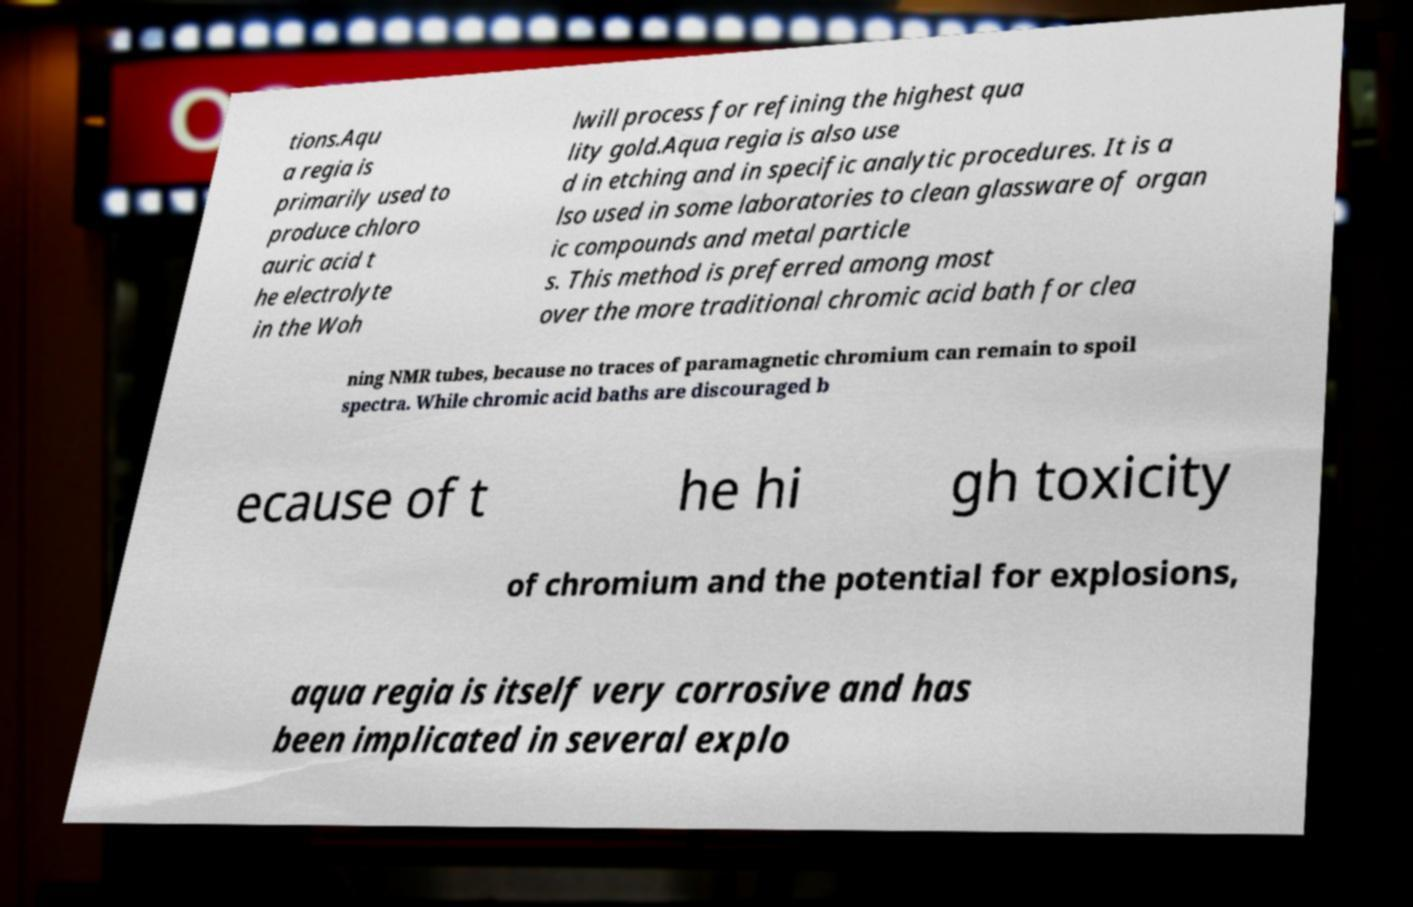What messages or text are displayed in this image? I need them in a readable, typed format. tions.Aqu a regia is primarily used to produce chloro auric acid t he electrolyte in the Woh lwill process for refining the highest qua lity gold.Aqua regia is also use d in etching and in specific analytic procedures. It is a lso used in some laboratories to clean glassware of organ ic compounds and metal particle s. This method is preferred among most over the more traditional chromic acid bath for clea ning NMR tubes, because no traces of paramagnetic chromium can remain to spoil spectra. While chromic acid baths are discouraged b ecause of t he hi gh toxicity of chromium and the potential for explosions, aqua regia is itself very corrosive and has been implicated in several explo 